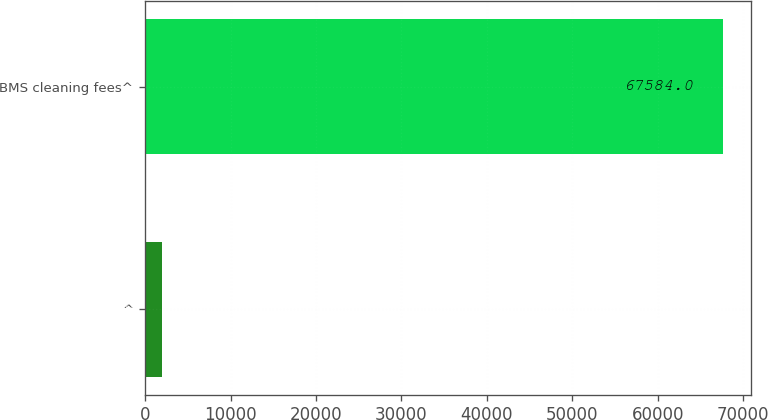<chart> <loc_0><loc_0><loc_500><loc_500><bar_chart><fcel>^<fcel>BMS cleaning fees^<nl><fcel>2012<fcel>67584<nl></chart> 